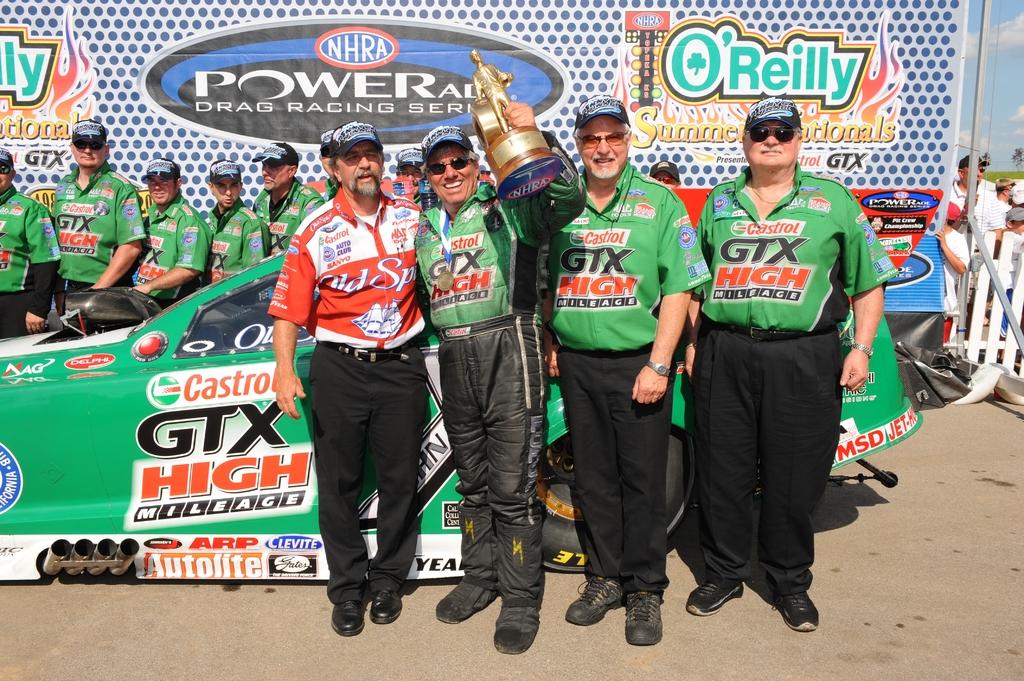What kind of race is happening?
Offer a terse response. Drag racing. Which organization is running this event?
Offer a terse response. Powerade. 